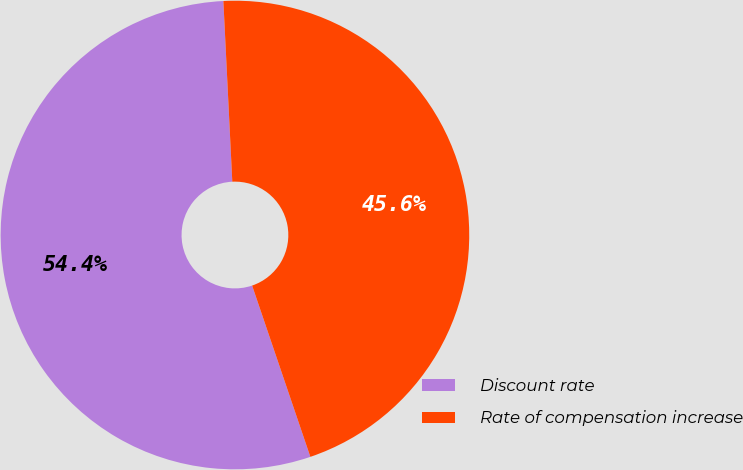<chart> <loc_0><loc_0><loc_500><loc_500><pie_chart><fcel>Discount rate<fcel>Rate of compensation increase<nl><fcel>54.43%<fcel>45.57%<nl></chart> 